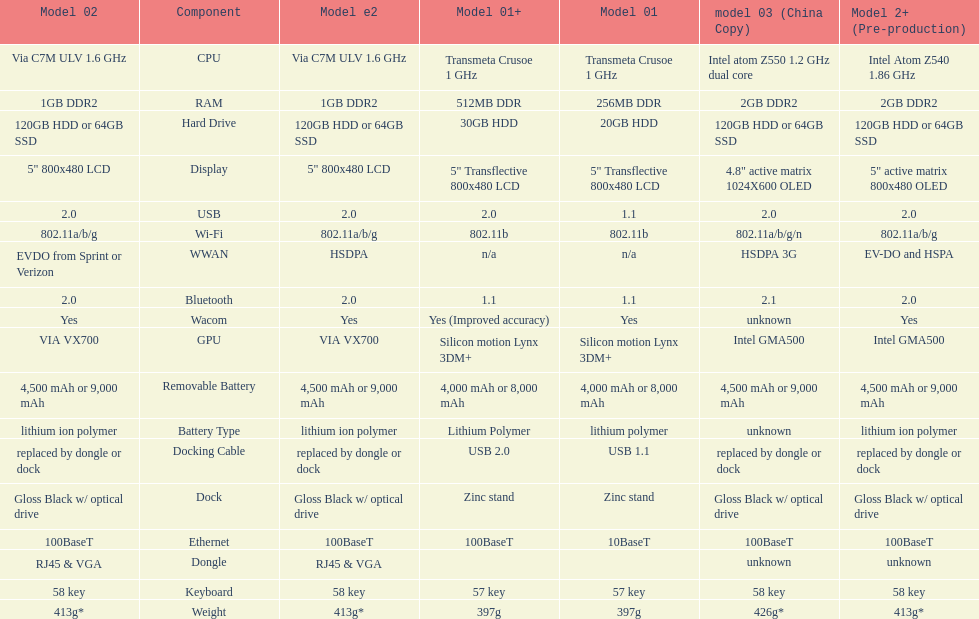How much more weight does the model 3 have over model 1? 29g. 